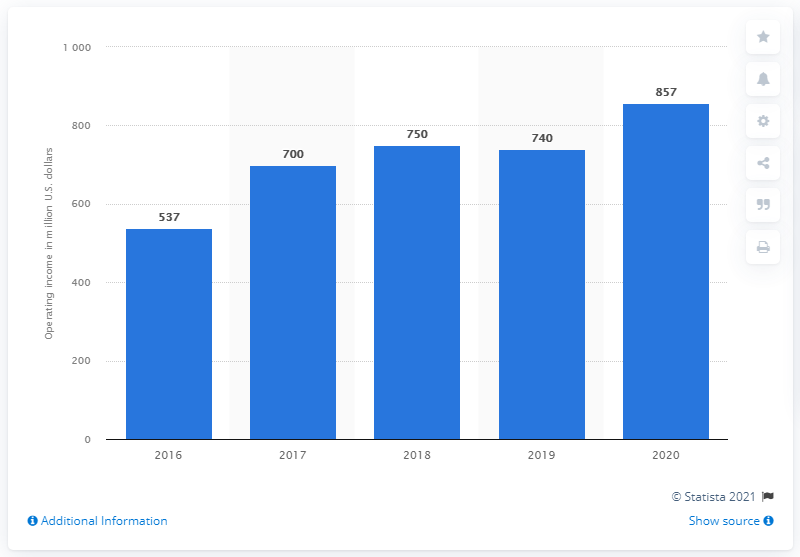Draw attention to some important aspects in this diagram. In 2020, the operating income of King.com was 857. 